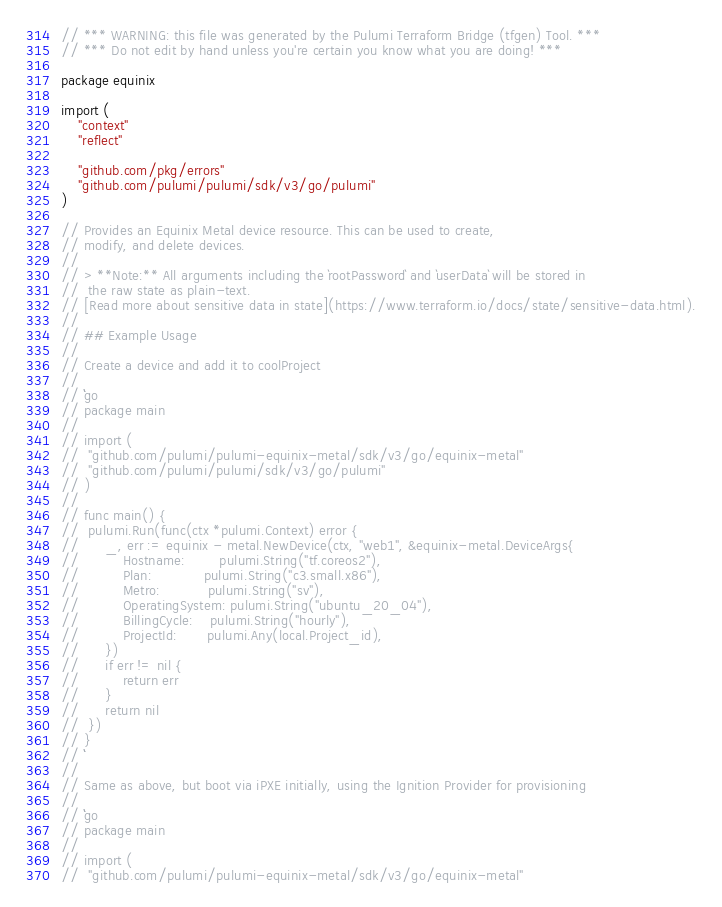<code> <loc_0><loc_0><loc_500><loc_500><_Go_>// *** WARNING: this file was generated by the Pulumi Terraform Bridge (tfgen) Tool. ***
// *** Do not edit by hand unless you're certain you know what you are doing! ***

package equinix

import (
	"context"
	"reflect"

	"github.com/pkg/errors"
	"github.com/pulumi/pulumi/sdk/v3/go/pulumi"
)

// Provides an Equinix Metal device resource. This can be used to create,
// modify, and delete devices.
//
// > **Note:** All arguments including the `rootPassword` and `userData` will be stored in
//  the raw state as plain-text.
// [Read more about sensitive data in state](https://www.terraform.io/docs/state/sensitive-data.html).
//
// ## Example Usage
//
// Create a device and add it to coolProject
//
// ```go
// package main
//
// import (
// 	"github.com/pulumi/pulumi-equinix-metal/sdk/v3/go/equinix-metal"
// 	"github.com/pulumi/pulumi/sdk/v3/go/pulumi"
// )
//
// func main() {
// 	pulumi.Run(func(ctx *pulumi.Context) error {
// 		_, err := equinix - metal.NewDevice(ctx, "web1", &equinix-metal.DeviceArgs{
// 			Hostname:        pulumi.String("tf.coreos2"),
// 			Plan:            pulumi.String("c3.small.x86"),
// 			Metro:           pulumi.String("sv"),
// 			OperatingSystem: pulumi.String("ubuntu_20_04"),
// 			BillingCycle:    pulumi.String("hourly"),
// 			ProjectId:       pulumi.Any(local.Project_id),
// 		})
// 		if err != nil {
// 			return err
// 		}
// 		return nil
// 	})
// }
// ```
//
// Same as above, but boot via iPXE initially, using the Ignition Provider for provisioning
//
// ```go
// package main
//
// import (
// 	"github.com/pulumi/pulumi-equinix-metal/sdk/v3/go/equinix-metal"</code> 